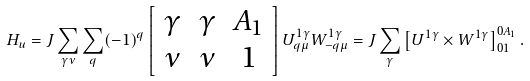<formula> <loc_0><loc_0><loc_500><loc_500>H _ { u } = J \sum _ { \gamma \nu } \sum _ { q } ( - 1 ) ^ { q } \left [ \begin{array} { c c c } \gamma & \gamma & A _ { 1 } \\ \nu & \nu & 1 \end{array} \right ] U _ { q \mu } ^ { 1 \gamma } W _ { - q \mu } ^ { 1 \gamma } = J \sum _ { \gamma } \left [ U ^ { 1 \gamma } \times W ^ { 1 \gamma } \right ] _ { 0 1 } ^ { 0 A _ { 1 } } .</formula> 